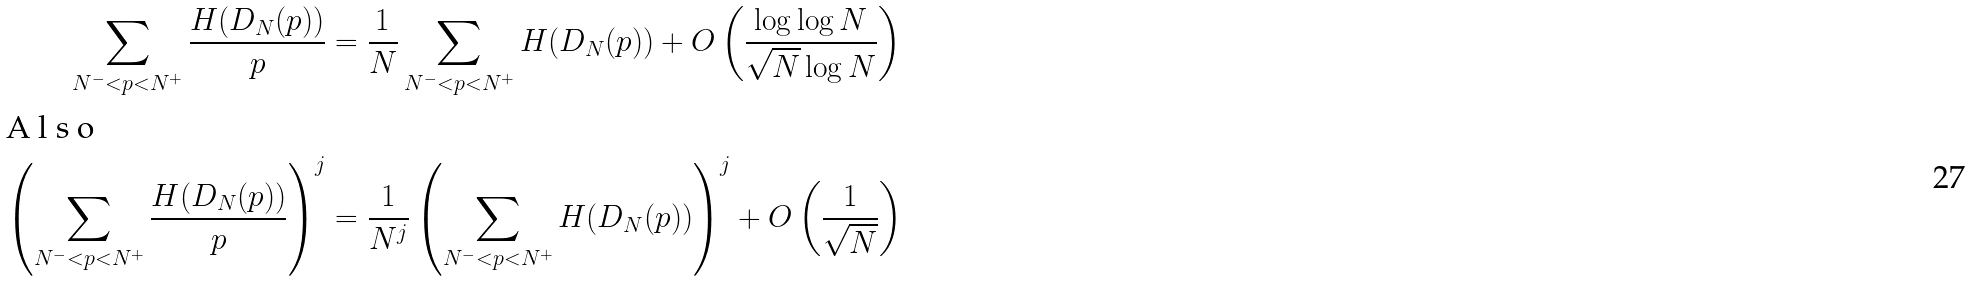<formula> <loc_0><loc_0><loc_500><loc_500>\sum _ { N ^ { - } < p < N ^ { + } } \frac { H ( D _ { N } ( p ) ) } { p } & = \frac { 1 } { N } \sum _ { N ^ { - } < p < N ^ { + } } H ( D _ { N } ( p ) ) + O \left ( \frac { \log \log N } { \sqrt { N } \log N } \right ) \intertext { A l s o } \left ( \sum _ { N ^ { - } < p < N ^ { + } } \frac { H ( D _ { N } ( p ) ) } { p } \right ) ^ { j } & = \frac { 1 } { N ^ { j } } \left ( \sum _ { N ^ { - } < p < N ^ { + } } H ( D _ { N } ( p ) ) \right ) ^ { j } + O \left ( \frac { 1 } { \sqrt { N } } \right )</formula> 